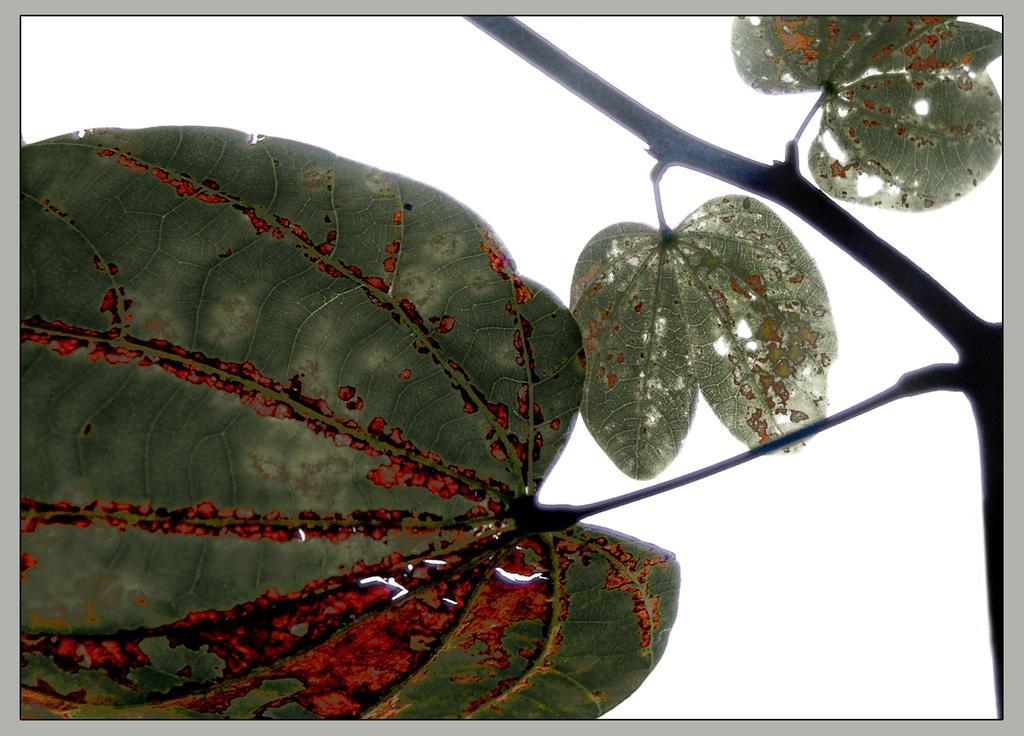Can you describe this image briefly? In this image I can see few green colour leaves and I can also see white colour in the background and on the right side of this image I can see stems. 